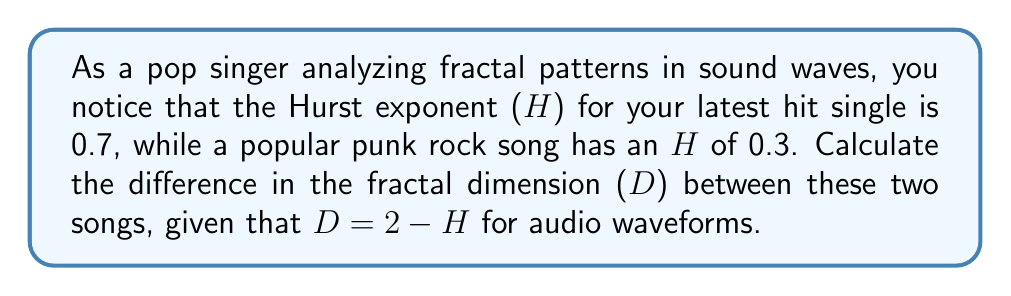Help me with this question. To solve this problem, we need to follow these steps:

1. Calculate the fractal dimension (D) for the pop song:
   $$D_{pop} = 2 - H_{pop}$$
   $$D_{pop} = 2 - 0.7 = 1.3$$

2. Calculate the fractal dimension (D) for the punk rock song:
   $$D_{punk} = 2 - H_{punk}$$
   $$D_{punk} = 2 - 0.3 = 1.7$$

3. Calculate the difference in fractal dimension:
   $$\Delta D = D_{punk} - D_{pop}$$
   $$\Delta D = 1.7 - 1.3 = 0.4$$

The positive difference indicates that the punk rock song has a higher fractal dimension, suggesting more complexity and roughness in its sound wave compared to the pop song.
Answer: 0.4 